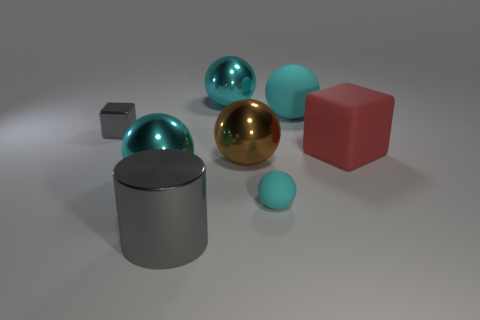Subtract all red cubes. How many cyan spheres are left? 4 Subtract 1 balls. How many balls are left? 4 Subtract all purple balls. Subtract all brown cubes. How many balls are left? 5 Add 1 small brown rubber spheres. How many objects exist? 9 Subtract all blocks. How many objects are left? 6 Subtract 1 brown spheres. How many objects are left? 7 Subtract all purple metallic balls. Subtract all gray things. How many objects are left? 6 Add 1 brown spheres. How many brown spheres are left? 2 Add 8 cyan shiny things. How many cyan shiny things exist? 10 